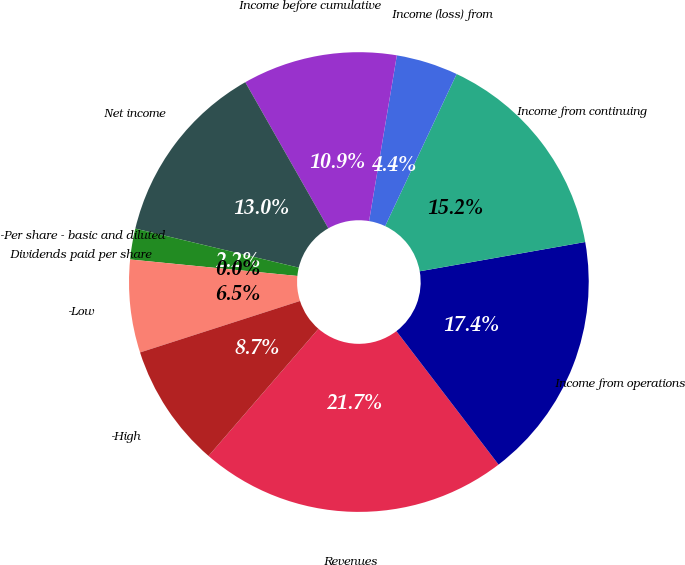Convert chart to OTSL. <chart><loc_0><loc_0><loc_500><loc_500><pie_chart><fcel>Revenues<fcel>Income from operations<fcel>Income from continuing<fcel>Income (loss) from<fcel>Income before cumulative<fcel>Net income<fcel>-Per share - basic and diluted<fcel>Dividends paid per share<fcel>-Low<fcel>-High<nl><fcel>21.74%<fcel>17.39%<fcel>15.22%<fcel>4.35%<fcel>10.87%<fcel>13.04%<fcel>2.17%<fcel>0.0%<fcel>6.52%<fcel>8.7%<nl></chart> 